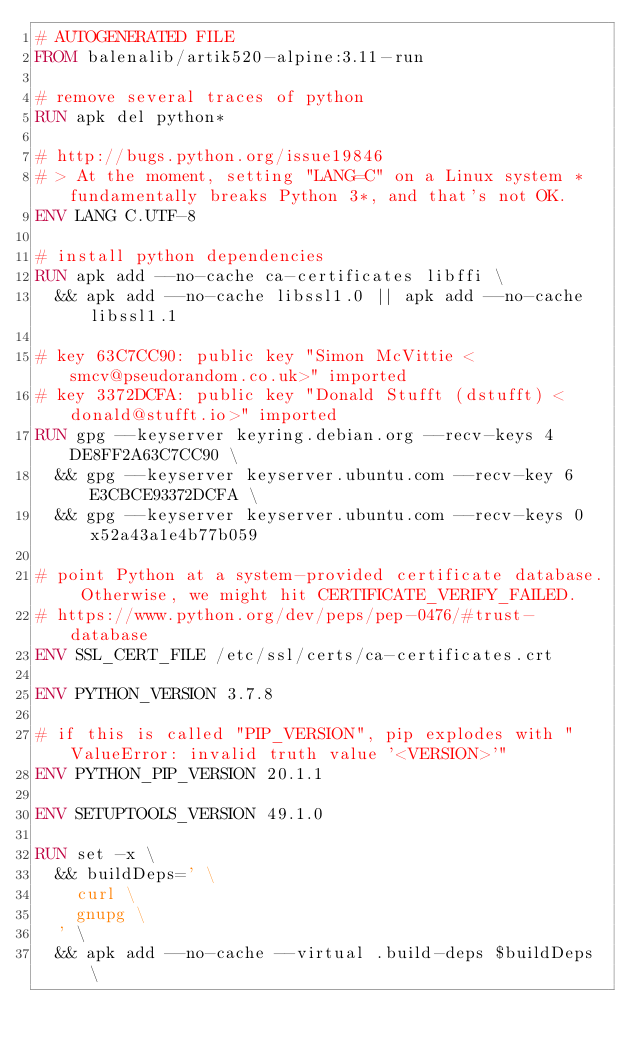Convert code to text. <code><loc_0><loc_0><loc_500><loc_500><_Dockerfile_># AUTOGENERATED FILE
FROM balenalib/artik520-alpine:3.11-run

# remove several traces of python
RUN apk del python*

# http://bugs.python.org/issue19846
# > At the moment, setting "LANG=C" on a Linux system *fundamentally breaks Python 3*, and that's not OK.
ENV LANG C.UTF-8

# install python dependencies
RUN apk add --no-cache ca-certificates libffi \
	&& apk add --no-cache libssl1.0 || apk add --no-cache libssl1.1

# key 63C7CC90: public key "Simon McVittie <smcv@pseudorandom.co.uk>" imported
# key 3372DCFA: public key "Donald Stufft (dstufft) <donald@stufft.io>" imported
RUN gpg --keyserver keyring.debian.org --recv-keys 4DE8FF2A63C7CC90 \
	&& gpg --keyserver keyserver.ubuntu.com --recv-key 6E3CBCE93372DCFA \
	&& gpg --keyserver keyserver.ubuntu.com --recv-keys 0x52a43a1e4b77b059

# point Python at a system-provided certificate database. Otherwise, we might hit CERTIFICATE_VERIFY_FAILED.
# https://www.python.org/dev/peps/pep-0476/#trust-database
ENV SSL_CERT_FILE /etc/ssl/certs/ca-certificates.crt

ENV PYTHON_VERSION 3.7.8

# if this is called "PIP_VERSION", pip explodes with "ValueError: invalid truth value '<VERSION>'"
ENV PYTHON_PIP_VERSION 20.1.1

ENV SETUPTOOLS_VERSION 49.1.0

RUN set -x \
	&& buildDeps=' \
		curl \
		gnupg \
	' \
	&& apk add --no-cache --virtual .build-deps $buildDeps \</code> 